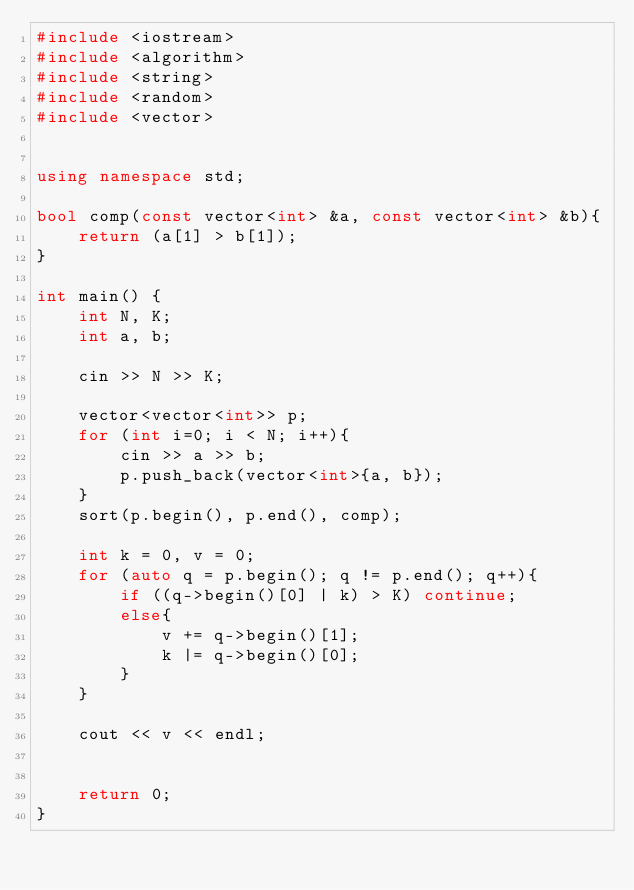<code> <loc_0><loc_0><loc_500><loc_500><_C++_>#include <iostream>
#include <algorithm>
#include <string>
#include <random>
#include <vector>


using namespace std;

bool comp(const vector<int> &a, const vector<int> &b){
    return (a[1] > b[1]);
}

int main() {
    int N, K;
    int a, b;

    cin >> N >> K;

    vector<vector<int>> p;
    for (int i=0; i < N; i++){
        cin >> a >> b;
        p.push_back(vector<int>{a, b});
    }
    sort(p.begin(), p.end(), comp);

    int k = 0, v = 0;
    for (auto q = p.begin(); q != p.end(); q++){
        if ((q->begin()[0] | k) > K) continue;
        else{
            v += q->begin()[1];
            k |= q->begin()[0];
        }
    }

    cout << v << endl;


    return 0;
}</code> 